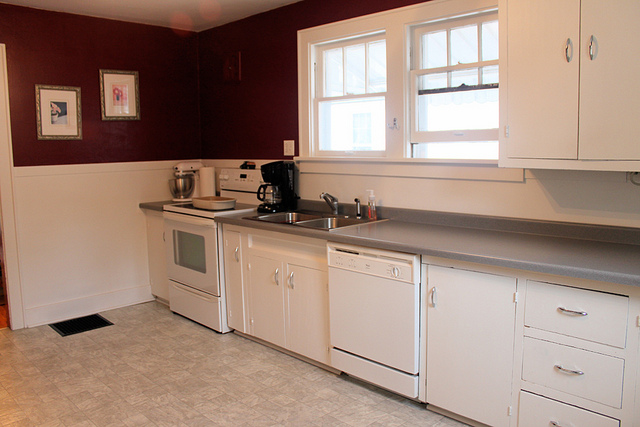How many cabinets can you see? There are a total of 6 cabinets visible in the image, providing ample storage space in the kitchen. 